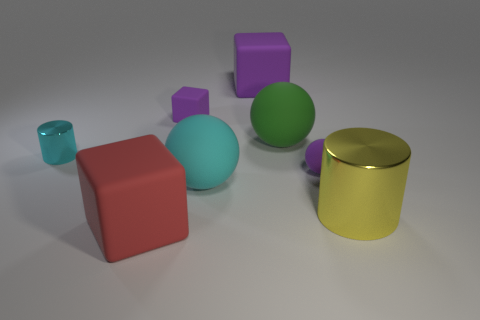What size is the cylinder in front of the tiny cyan cylinder?
Provide a succinct answer. Large. What number of small objects have the same color as the tiny ball?
Keep it short and to the point. 1. How many cylinders are red rubber objects or small things?
Make the answer very short. 1. The object that is in front of the big cyan matte object and to the left of the small rubber block has what shape?
Keep it short and to the point. Cube. Is there a purple matte thing of the same size as the red thing?
Keep it short and to the point. Yes. What number of objects are matte blocks that are behind the big cylinder or large objects?
Ensure brevity in your answer.  6. Are the large green object and the large cube that is behind the large yellow metal thing made of the same material?
Give a very brief answer. Yes. What number of other objects are the same shape as the cyan metal object?
Provide a short and direct response. 1. How many things are small purple objects to the left of the small sphere or large objects that are behind the large yellow metallic cylinder?
Make the answer very short. 4. What number of other things are the same color as the tiny cube?
Offer a terse response. 2. 